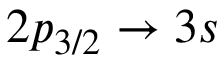Convert formula to latex. <formula><loc_0><loc_0><loc_500><loc_500>2 p _ { 3 / 2 } \rightarrow 3 s</formula> 